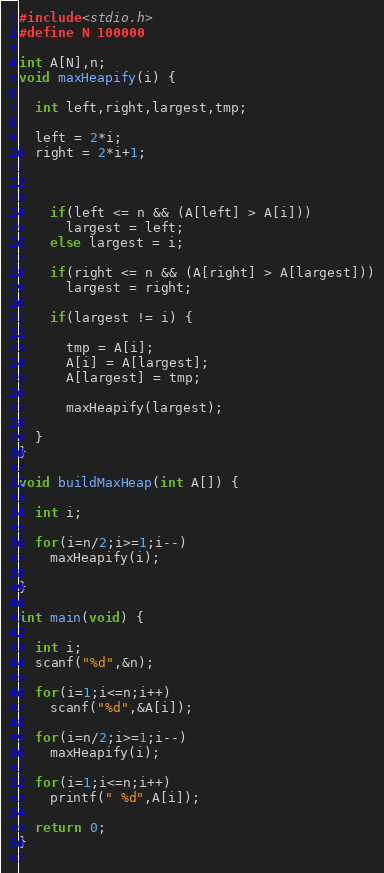<code> <loc_0><loc_0><loc_500><loc_500><_C_>#include<stdio.h>
#define N 100000

int A[N],n;
void maxHeapify(i) {
  
  int left,right,largest,tmp;
  
  left = 2*i;
  right = 2*i+1;
  
 
    
    if(left <= n && (A[left] > A[i]))
      largest = left;
    else largest = i;
    
    if(right <= n && (A[right] > A[largest]))
      largest = right;
    
    if(largest != i) {
      
      tmp = A[i];
      A[i] = A[largest];
      A[largest] = tmp;
      
      maxHeapify(largest);
    
  }
}

void buildMaxHeap(int A[]) {

  int i;

  for(i=n/2;i>=1;i--)
    maxHeapify(i);

}

int main(void) {
  
  int i;
  scanf("%d",&n);
  
  for(i=1;i<=n;i++) 
    scanf("%d",&A[i]);
  
  for(i=n/2;i>=1;i--) 
    maxHeapify(i);
  
  for(i=1;i<=n;i++)
    printf(" %d",A[i]);
  
  return 0;
}
 </code> 